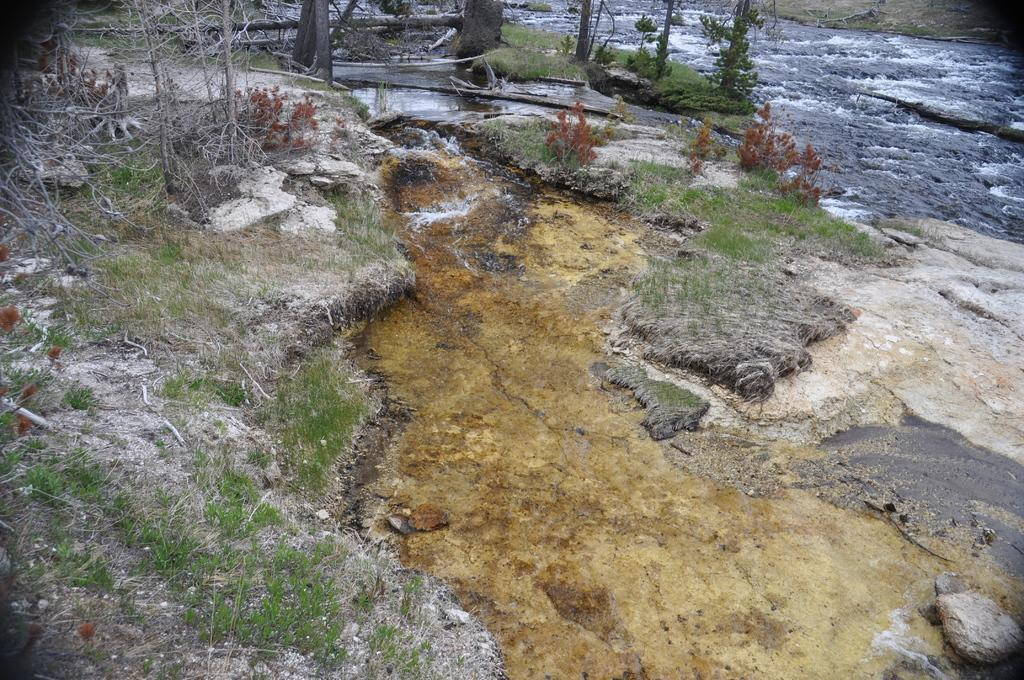What is one of the main elements in the picture? There is water in the picture. What type of vegetation can be seen in the picture? There is grass and plants in the picture. What else can be seen in the picture? There are tree trunks in the picture. How many rabbits are hopping in the group near the tree trunks? There are no rabbits present in the image. What type of iron is being used to water the plants in the picture? There is no iron visible in the image, and the plants do not appear to be watered. 